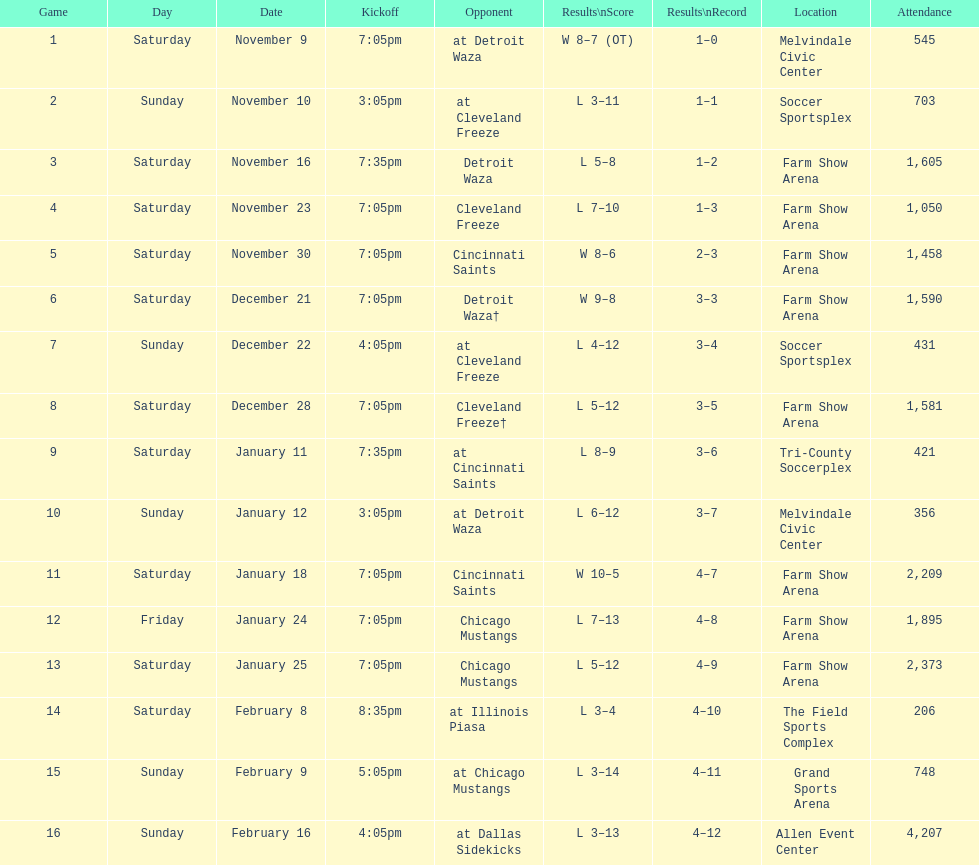What was the position before tri-county soccerplex? Farm Show Arena. 